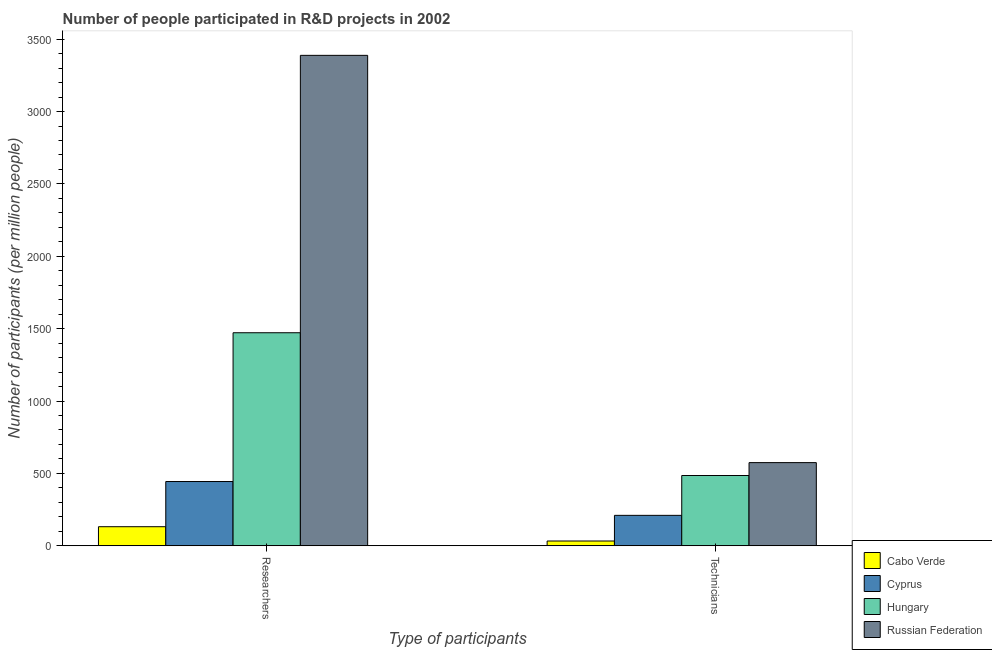Are the number of bars per tick equal to the number of legend labels?
Make the answer very short. Yes. Are the number of bars on each tick of the X-axis equal?
Your response must be concise. Yes. How many bars are there on the 2nd tick from the left?
Provide a succinct answer. 4. What is the label of the 1st group of bars from the left?
Your answer should be very brief. Researchers. What is the number of researchers in Cabo Verde?
Provide a short and direct response. 131.75. Across all countries, what is the maximum number of researchers?
Ensure brevity in your answer.  3388.15. Across all countries, what is the minimum number of researchers?
Keep it short and to the point. 131.75. In which country was the number of technicians maximum?
Ensure brevity in your answer.  Russian Federation. In which country was the number of researchers minimum?
Offer a terse response. Cabo Verde. What is the total number of technicians in the graph?
Your answer should be compact. 1303.09. What is the difference between the number of technicians in Cyprus and that in Cabo Verde?
Provide a short and direct response. 177.29. What is the difference between the number of technicians in Cabo Verde and the number of researchers in Hungary?
Ensure brevity in your answer.  -1438.82. What is the average number of technicians per country?
Keep it short and to the point. 325.77. What is the difference between the number of technicians and number of researchers in Russian Federation?
Provide a short and direct response. -2813.66. In how many countries, is the number of researchers greater than 600 ?
Provide a short and direct response. 2. What is the ratio of the number of technicians in Russian Federation to that in Hungary?
Offer a very short reply. 1.18. What does the 2nd bar from the left in Technicians represents?
Provide a succinct answer. Cyprus. What does the 1st bar from the right in Technicians represents?
Ensure brevity in your answer.  Russian Federation. Are all the bars in the graph horizontal?
Ensure brevity in your answer.  No. How many countries are there in the graph?
Offer a terse response. 4. Are the values on the major ticks of Y-axis written in scientific E-notation?
Give a very brief answer. No. Does the graph contain grids?
Your response must be concise. No. Where does the legend appear in the graph?
Offer a terse response. Bottom right. What is the title of the graph?
Offer a terse response. Number of people participated in R&D projects in 2002. Does "St. Vincent and the Grenadines" appear as one of the legend labels in the graph?
Your response must be concise. No. What is the label or title of the X-axis?
Make the answer very short. Type of participants. What is the label or title of the Y-axis?
Make the answer very short. Number of participants (per million people). What is the Number of participants (per million people) in Cabo Verde in Researchers?
Your answer should be compact. 131.75. What is the Number of participants (per million people) of Cyprus in Researchers?
Give a very brief answer. 443.93. What is the Number of participants (per million people) of Hungary in Researchers?
Provide a succinct answer. 1471.76. What is the Number of participants (per million people) in Russian Federation in Researchers?
Provide a short and direct response. 3388.15. What is the Number of participants (per million people) in Cabo Verde in Technicians?
Provide a succinct answer. 32.94. What is the Number of participants (per million people) in Cyprus in Technicians?
Keep it short and to the point. 210.23. What is the Number of participants (per million people) of Hungary in Technicians?
Provide a short and direct response. 485.44. What is the Number of participants (per million people) of Russian Federation in Technicians?
Ensure brevity in your answer.  574.49. Across all Type of participants, what is the maximum Number of participants (per million people) in Cabo Verde?
Offer a very short reply. 131.75. Across all Type of participants, what is the maximum Number of participants (per million people) of Cyprus?
Provide a succinct answer. 443.93. Across all Type of participants, what is the maximum Number of participants (per million people) in Hungary?
Offer a very short reply. 1471.76. Across all Type of participants, what is the maximum Number of participants (per million people) in Russian Federation?
Provide a succinct answer. 3388.15. Across all Type of participants, what is the minimum Number of participants (per million people) in Cabo Verde?
Ensure brevity in your answer.  32.94. Across all Type of participants, what is the minimum Number of participants (per million people) of Cyprus?
Provide a short and direct response. 210.23. Across all Type of participants, what is the minimum Number of participants (per million people) in Hungary?
Your answer should be compact. 485.44. Across all Type of participants, what is the minimum Number of participants (per million people) of Russian Federation?
Give a very brief answer. 574.49. What is the total Number of participants (per million people) of Cabo Verde in the graph?
Your answer should be very brief. 164.69. What is the total Number of participants (per million people) of Cyprus in the graph?
Keep it short and to the point. 654.16. What is the total Number of participants (per million people) in Hungary in the graph?
Offer a terse response. 1957.2. What is the total Number of participants (per million people) in Russian Federation in the graph?
Make the answer very short. 3962.64. What is the difference between the Number of participants (per million people) in Cabo Verde in Researchers and that in Technicians?
Ensure brevity in your answer.  98.82. What is the difference between the Number of participants (per million people) in Cyprus in Researchers and that in Technicians?
Offer a very short reply. 233.7. What is the difference between the Number of participants (per million people) of Hungary in Researchers and that in Technicians?
Your answer should be very brief. 986.32. What is the difference between the Number of participants (per million people) of Russian Federation in Researchers and that in Technicians?
Your answer should be compact. 2813.66. What is the difference between the Number of participants (per million people) of Cabo Verde in Researchers and the Number of participants (per million people) of Cyprus in Technicians?
Offer a terse response. -78.48. What is the difference between the Number of participants (per million people) of Cabo Verde in Researchers and the Number of participants (per million people) of Hungary in Technicians?
Ensure brevity in your answer.  -353.69. What is the difference between the Number of participants (per million people) of Cabo Verde in Researchers and the Number of participants (per million people) of Russian Federation in Technicians?
Your answer should be very brief. -442.73. What is the difference between the Number of participants (per million people) of Cyprus in Researchers and the Number of participants (per million people) of Hungary in Technicians?
Keep it short and to the point. -41.51. What is the difference between the Number of participants (per million people) in Cyprus in Researchers and the Number of participants (per million people) in Russian Federation in Technicians?
Keep it short and to the point. -130.56. What is the difference between the Number of participants (per million people) in Hungary in Researchers and the Number of participants (per million people) in Russian Federation in Technicians?
Offer a very short reply. 897.27. What is the average Number of participants (per million people) of Cabo Verde per Type of participants?
Provide a short and direct response. 82.35. What is the average Number of participants (per million people) in Cyprus per Type of participants?
Offer a very short reply. 327.08. What is the average Number of participants (per million people) in Hungary per Type of participants?
Provide a succinct answer. 978.6. What is the average Number of participants (per million people) of Russian Federation per Type of participants?
Make the answer very short. 1981.32. What is the difference between the Number of participants (per million people) in Cabo Verde and Number of participants (per million people) in Cyprus in Researchers?
Your answer should be compact. -312.18. What is the difference between the Number of participants (per million people) of Cabo Verde and Number of participants (per million people) of Hungary in Researchers?
Offer a terse response. -1340.01. What is the difference between the Number of participants (per million people) in Cabo Verde and Number of participants (per million people) in Russian Federation in Researchers?
Give a very brief answer. -3256.4. What is the difference between the Number of participants (per million people) of Cyprus and Number of participants (per million people) of Hungary in Researchers?
Your answer should be very brief. -1027.83. What is the difference between the Number of participants (per million people) of Cyprus and Number of participants (per million people) of Russian Federation in Researchers?
Your answer should be compact. -2944.22. What is the difference between the Number of participants (per million people) of Hungary and Number of participants (per million people) of Russian Federation in Researchers?
Offer a terse response. -1916.39. What is the difference between the Number of participants (per million people) in Cabo Verde and Number of participants (per million people) in Cyprus in Technicians?
Ensure brevity in your answer.  -177.29. What is the difference between the Number of participants (per million people) in Cabo Verde and Number of participants (per million people) in Hungary in Technicians?
Keep it short and to the point. -452.5. What is the difference between the Number of participants (per million people) in Cabo Verde and Number of participants (per million people) in Russian Federation in Technicians?
Your answer should be compact. -541.55. What is the difference between the Number of participants (per million people) in Cyprus and Number of participants (per million people) in Hungary in Technicians?
Offer a terse response. -275.21. What is the difference between the Number of participants (per million people) of Cyprus and Number of participants (per million people) of Russian Federation in Technicians?
Give a very brief answer. -364.26. What is the difference between the Number of participants (per million people) in Hungary and Number of participants (per million people) in Russian Federation in Technicians?
Provide a succinct answer. -89.05. What is the ratio of the Number of participants (per million people) of Cyprus in Researchers to that in Technicians?
Provide a short and direct response. 2.11. What is the ratio of the Number of participants (per million people) in Hungary in Researchers to that in Technicians?
Offer a terse response. 3.03. What is the ratio of the Number of participants (per million people) of Russian Federation in Researchers to that in Technicians?
Provide a short and direct response. 5.9. What is the difference between the highest and the second highest Number of participants (per million people) of Cabo Verde?
Give a very brief answer. 98.82. What is the difference between the highest and the second highest Number of participants (per million people) in Cyprus?
Keep it short and to the point. 233.7. What is the difference between the highest and the second highest Number of participants (per million people) of Hungary?
Your answer should be very brief. 986.32. What is the difference between the highest and the second highest Number of participants (per million people) in Russian Federation?
Provide a succinct answer. 2813.66. What is the difference between the highest and the lowest Number of participants (per million people) of Cabo Verde?
Provide a succinct answer. 98.82. What is the difference between the highest and the lowest Number of participants (per million people) in Cyprus?
Your answer should be very brief. 233.7. What is the difference between the highest and the lowest Number of participants (per million people) of Hungary?
Your answer should be compact. 986.32. What is the difference between the highest and the lowest Number of participants (per million people) of Russian Federation?
Your response must be concise. 2813.66. 